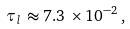Convert formula to latex. <formula><loc_0><loc_0><loc_500><loc_500>\tau _ { l } \, \approx 7 . 3 \, \times 1 0 ^ { - 2 } \, ,</formula> 